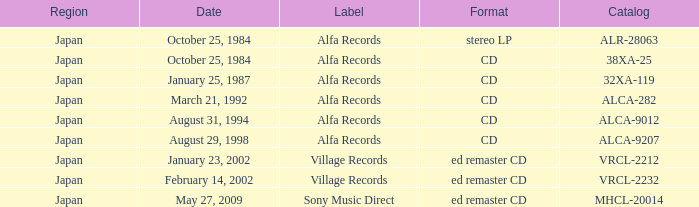What is the region of the Alfa Records release with catalog ALCA-282? Japan. 